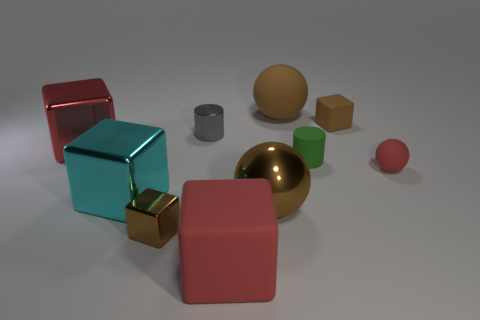Subtract 1 cubes. How many cubes are left? 4 Subtract all brown matte cubes. How many cubes are left? 4 Subtract all cyan cubes. How many cubes are left? 4 Subtract all purple spheres. Subtract all cyan cubes. How many spheres are left? 3 Subtract all cylinders. How many objects are left? 8 Add 8 big red matte things. How many big red matte things exist? 9 Subtract 0 green spheres. How many objects are left? 10 Subtract all brown metal objects. Subtract all green matte cylinders. How many objects are left? 7 Add 5 tiny cylinders. How many tiny cylinders are left? 7 